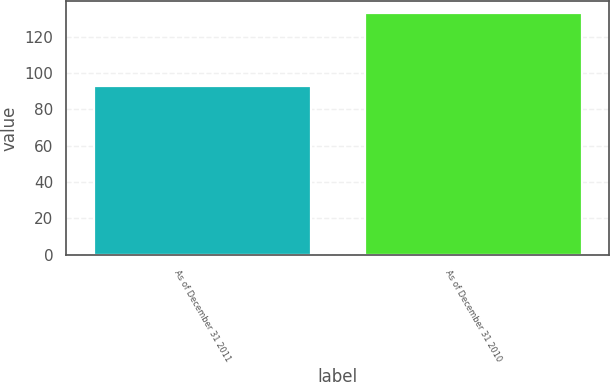Convert chart. <chart><loc_0><loc_0><loc_500><loc_500><bar_chart><fcel>As of December 31 2011<fcel>As of December 31 2010<nl><fcel>93<fcel>133<nl></chart> 